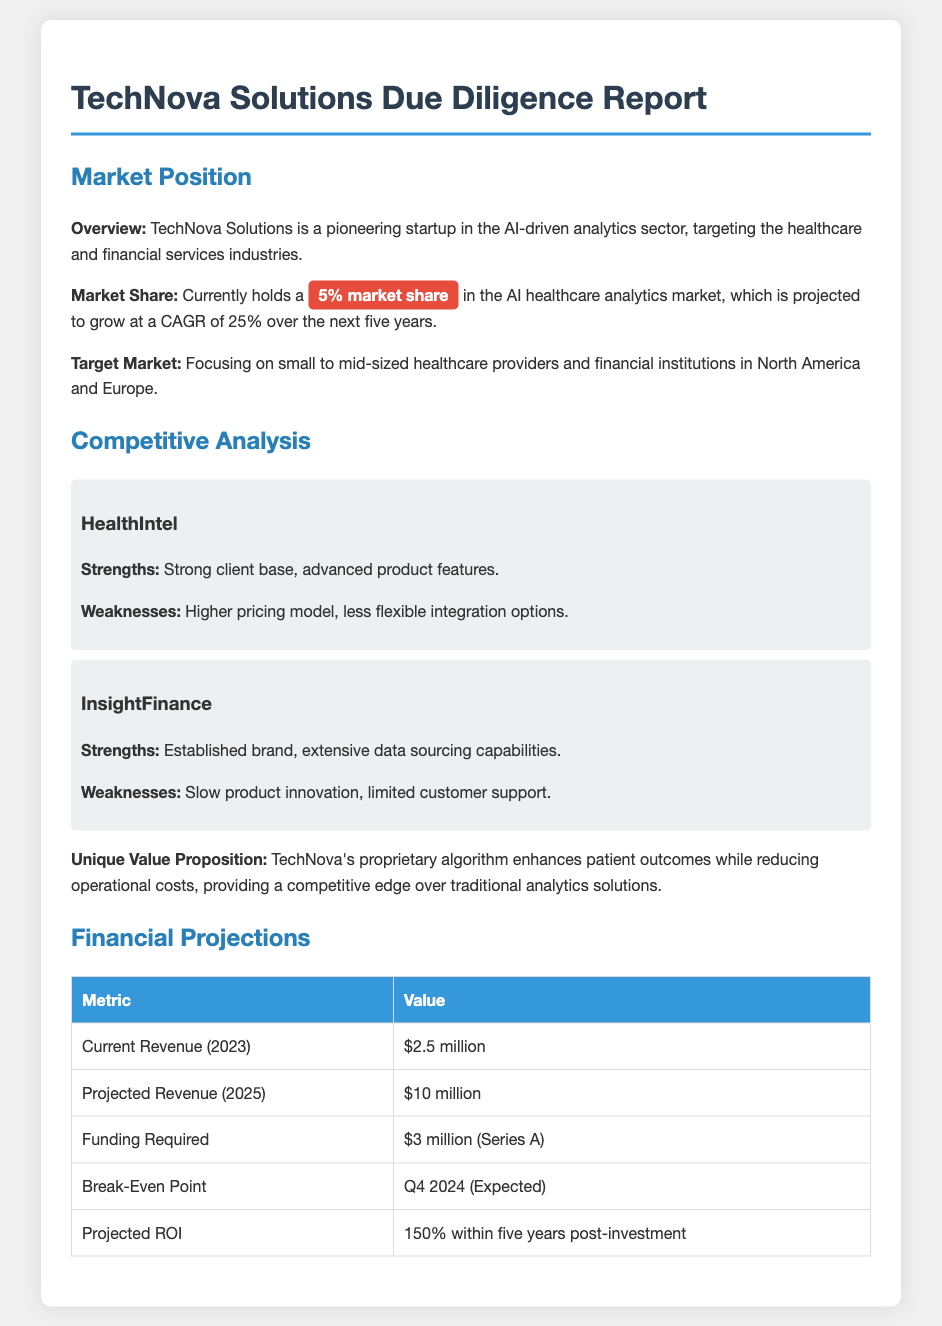What is the market share of TechNova Solutions? The document states that TechNova Solutions currently holds a 5% market share in the AI healthcare analytics market.
Answer: 5% What is the projected revenue for TechNova by 2025? The document provides the projected revenue figure for 2025, which is mentioned.
Answer: $10 million What sectors does TechNova target? The document explicitly mentions the sectors that TechNova Solutions is targeting.
Answer: Healthcare and financial services Who are TechNova's competitors mentioned in the report? The report lists two main competitors in the competitive analysis section.
Answer: HealthIntel and InsightFinance What is the funding required for TechNova Solutions? The document indicates the amount of funding TechNova is seeking for their Series A round.
Answer: $3 million What is TechNova's unique value proposition? The report highlights TechNova's unique value proposition that gives it a competitive edge over others.
Answer: Proprietary algorithm enhances patient outcomes while reducing operational costs When is the expected break-even point for TechNova? The document specifies the expected timeframe for TechNova to reach its break-even point.
Answer: Q4 2024 What is the projected ROI for the investment? The report outlines the expected return on investment within a specified period post-investment.
Answer: 150% within five years post-investment What market growth rate is projected for the next five years? The document mentions the projected CAGR for the AI healthcare analytics market over the next five years.
Answer: 25% 